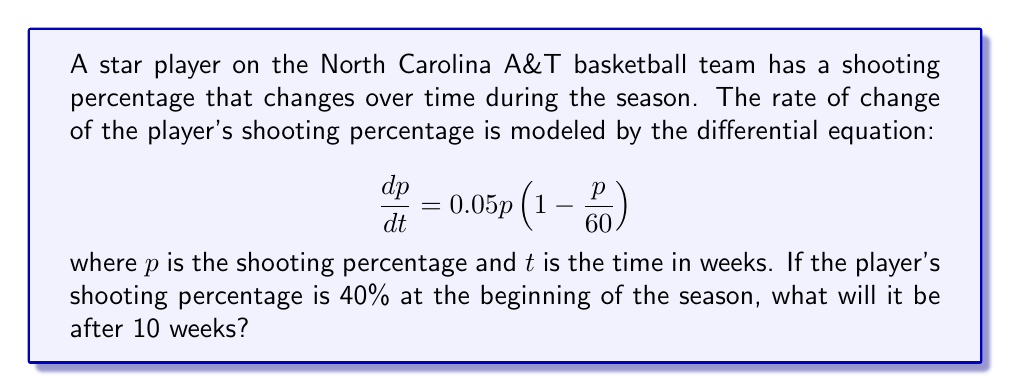What is the answer to this math problem? To solve this problem, we need to use the separation of variables method for first-order differential equations.

1. Rearrange the equation:
   $$\frac{dp}{p(1-\frac{p}{60})} = 0.05dt$$

2. Integrate both sides:
   $$\int \frac{dp}{p(1-\frac{p}{60})} = \int 0.05dt$$

3. The left side can be simplified using partial fractions:
   $$\int (\frac{1}{p} + \frac{1}{60-p})dp = 0.05t + C$$

4. Solve the integral:
   $$\ln|p| - \ln|60-p| = 0.05t + C$$

5. Simplify:
   $$\ln|\frac{p}{60-p}| = 0.05t + C$$

6. Apply the initial condition: $p(0) = 40$
   $$\ln|\frac{40}{60-40}| = C$$
   $$\ln|2| = C$$

7. Substitute back into the general solution:
   $$\ln|\frac{p}{60-p}| = 0.05t + \ln|2|$$

8. Solve for $p$:
   $$\frac{p}{60-p} = 2e^{0.05t}$$
   $$p = 120e^{0.05t} - 2pe^{0.05t}$$
   $$p(1+2e^{0.05t}) = 120e^{0.05t}$$
   $$p = \frac{120e^{0.05t}}{1+2e^{0.05t}}$$

9. Evaluate at $t=10$:
   $$p(10) = \frac{120e^{0.5}}{1+2e^{0.5}} \approx 52.31$$
Answer: The player's shooting percentage after 10 weeks will be approximately 52.31%. 